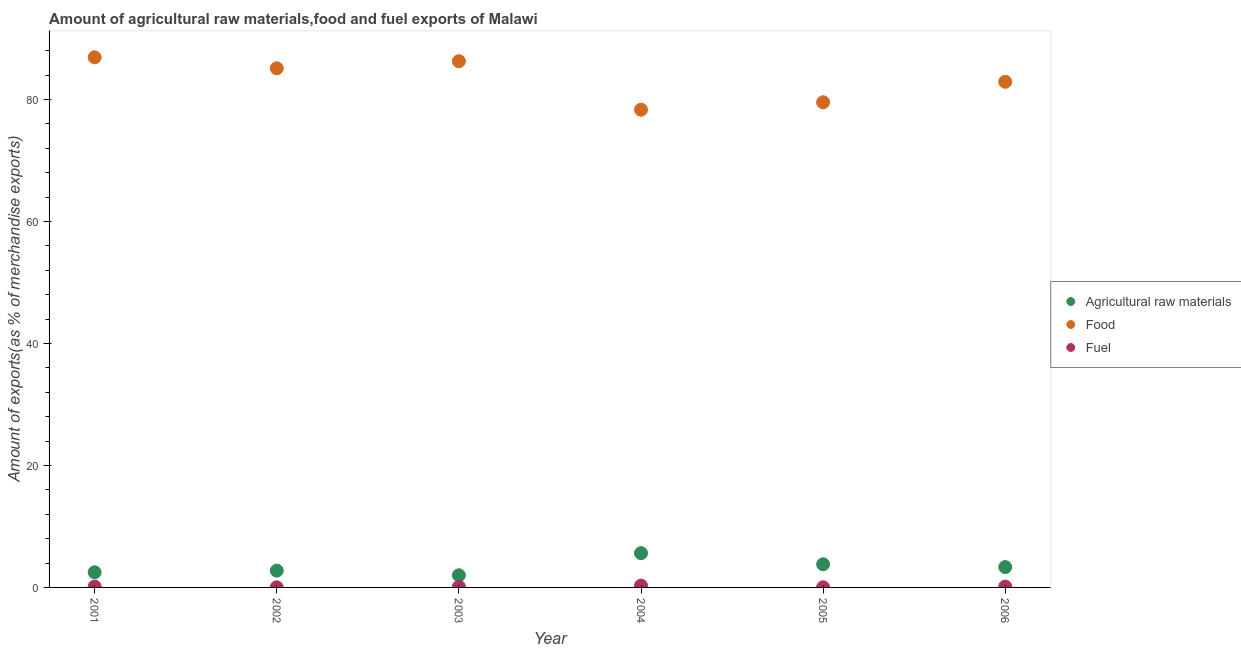Is the number of dotlines equal to the number of legend labels?
Ensure brevity in your answer.  Yes. What is the percentage of raw materials exports in 2006?
Make the answer very short. 3.33. Across all years, what is the maximum percentage of food exports?
Provide a succinct answer. 86.9. Across all years, what is the minimum percentage of food exports?
Your answer should be very brief. 78.32. In which year was the percentage of fuel exports maximum?
Make the answer very short. 2004. In which year was the percentage of fuel exports minimum?
Provide a succinct answer. 2002. What is the total percentage of fuel exports in the graph?
Make the answer very short. 0.73. What is the difference between the percentage of food exports in 2001 and that in 2003?
Make the answer very short. 0.64. What is the difference between the percentage of food exports in 2001 and the percentage of fuel exports in 2004?
Provide a succinct answer. 86.6. What is the average percentage of raw materials exports per year?
Provide a short and direct response. 3.33. In the year 2002, what is the difference between the percentage of fuel exports and percentage of food exports?
Your response must be concise. -85.09. In how many years, is the percentage of food exports greater than 68 %?
Ensure brevity in your answer.  6. What is the ratio of the percentage of food exports in 2001 to that in 2004?
Provide a succinct answer. 1.11. Is the percentage of raw materials exports in 2001 less than that in 2004?
Your answer should be very brief. Yes. Is the difference between the percentage of food exports in 2001 and 2002 greater than the difference between the percentage of raw materials exports in 2001 and 2002?
Give a very brief answer. Yes. What is the difference between the highest and the second highest percentage of food exports?
Keep it short and to the point. 0.64. What is the difference between the highest and the lowest percentage of raw materials exports?
Give a very brief answer. 3.62. In how many years, is the percentage of food exports greater than the average percentage of food exports taken over all years?
Make the answer very short. 3. Is it the case that in every year, the sum of the percentage of raw materials exports and percentage of food exports is greater than the percentage of fuel exports?
Your answer should be compact. Yes. Is the percentage of food exports strictly greater than the percentage of raw materials exports over the years?
Offer a very short reply. Yes. How many years are there in the graph?
Make the answer very short. 6. What is the difference between two consecutive major ticks on the Y-axis?
Keep it short and to the point. 20. Where does the legend appear in the graph?
Make the answer very short. Center right. How many legend labels are there?
Provide a succinct answer. 3. How are the legend labels stacked?
Your answer should be very brief. Vertical. What is the title of the graph?
Make the answer very short. Amount of agricultural raw materials,food and fuel exports of Malawi. Does "Transport services" appear as one of the legend labels in the graph?
Provide a short and direct response. No. What is the label or title of the X-axis?
Keep it short and to the point. Year. What is the label or title of the Y-axis?
Provide a short and direct response. Amount of exports(as % of merchandise exports). What is the Amount of exports(as % of merchandise exports) in Agricultural raw materials in 2001?
Offer a terse response. 2.48. What is the Amount of exports(as % of merchandise exports) of Food in 2001?
Keep it short and to the point. 86.9. What is the Amount of exports(as % of merchandise exports) in Fuel in 2001?
Offer a very short reply. 0.14. What is the Amount of exports(as % of merchandise exports) of Agricultural raw materials in 2002?
Offer a very short reply. 2.75. What is the Amount of exports(as % of merchandise exports) of Food in 2002?
Provide a short and direct response. 85.11. What is the Amount of exports(as % of merchandise exports) of Fuel in 2002?
Offer a terse response. 0.02. What is the Amount of exports(as % of merchandise exports) in Agricultural raw materials in 2003?
Ensure brevity in your answer.  2. What is the Amount of exports(as % of merchandise exports) in Food in 2003?
Ensure brevity in your answer.  86.27. What is the Amount of exports(as % of merchandise exports) in Fuel in 2003?
Your answer should be very brief. 0.11. What is the Amount of exports(as % of merchandise exports) in Agricultural raw materials in 2004?
Your answer should be compact. 5.62. What is the Amount of exports(as % of merchandise exports) of Food in 2004?
Give a very brief answer. 78.32. What is the Amount of exports(as % of merchandise exports) in Fuel in 2004?
Provide a succinct answer. 0.3. What is the Amount of exports(as % of merchandise exports) of Agricultural raw materials in 2005?
Make the answer very short. 3.8. What is the Amount of exports(as % of merchandise exports) in Food in 2005?
Give a very brief answer. 79.54. What is the Amount of exports(as % of merchandise exports) of Fuel in 2005?
Provide a succinct answer. 0.02. What is the Amount of exports(as % of merchandise exports) of Agricultural raw materials in 2006?
Your response must be concise. 3.33. What is the Amount of exports(as % of merchandise exports) in Food in 2006?
Give a very brief answer. 82.9. What is the Amount of exports(as % of merchandise exports) in Fuel in 2006?
Give a very brief answer. 0.14. Across all years, what is the maximum Amount of exports(as % of merchandise exports) in Agricultural raw materials?
Ensure brevity in your answer.  5.62. Across all years, what is the maximum Amount of exports(as % of merchandise exports) in Food?
Your answer should be compact. 86.9. Across all years, what is the maximum Amount of exports(as % of merchandise exports) of Fuel?
Offer a very short reply. 0.3. Across all years, what is the minimum Amount of exports(as % of merchandise exports) in Agricultural raw materials?
Make the answer very short. 2. Across all years, what is the minimum Amount of exports(as % of merchandise exports) in Food?
Provide a short and direct response. 78.32. Across all years, what is the minimum Amount of exports(as % of merchandise exports) of Fuel?
Your answer should be compact. 0.02. What is the total Amount of exports(as % of merchandise exports) of Agricultural raw materials in the graph?
Your answer should be very brief. 19.97. What is the total Amount of exports(as % of merchandise exports) in Food in the graph?
Offer a very short reply. 499.03. What is the total Amount of exports(as % of merchandise exports) of Fuel in the graph?
Give a very brief answer. 0.73. What is the difference between the Amount of exports(as % of merchandise exports) of Agricultural raw materials in 2001 and that in 2002?
Your answer should be compact. -0.28. What is the difference between the Amount of exports(as % of merchandise exports) in Food in 2001 and that in 2002?
Your answer should be compact. 1.8. What is the difference between the Amount of exports(as % of merchandise exports) of Fuel in 2001 and that in 2002?
Offer a terse response. 0.12. What is the difference between the Amount of exports(as % of merchandise exports) in Agricultural raw materials in 2001 and that in 2003?
Your answer should be very brief. 0.48. What is the difference between the Amount of exports(as % of merchandise exports) of Food in 2001 and that in 2003?
Make the answer very short. 0.64. What is the difference between the Amount of exports(as % of merchandise exports) in Fuel in 2001 and that in 2003?
Provide a short and direct response. 0.02. What is the difference between the Amount of exports(as % of merchandise exports) of Agricultural raw materials in 2001 and that in 2004?
Provide a succinct answer. -3.14. What is the difference between the Amount of exports(as % of merchandise exports) in Food in 2001 and that in 2004?
Provide a short and direct response. 8.59. What is the difference between the Amount of exports(as % of merchandise exports) in Fuel in 2001 and that in 2004?
Keep it short and to the point. -0.16. What is the difference between the Amount of exports(as % of merchandise exports) of Agricultural raw materials in 2001 and that in 2005?
Provide a short and direct response. -1.32. What is the difference between the Amount of exports(as % of merchandise exports) in Food in 2001 and that in 2005?
Your answer should be very brief. 7.37. What is the difference between the Amount of exports(as % of merchandise exports) of Fuel in 2001 and that in 2005?
Ensure brevity in your answer.  0.12. What is the difference between the Amount of exports(as % of merchandise exports) of Agricultural raw materials in 2001 and that in 2006?
Give a very brief answer. -0.86. What is the difference between the Amount of exports(as % of merchandise exports) of Food in 2001 and that in 2006?
Make the answer very short. 4.01. What is the difference between the Amount of exports(as % of merchandise exports) in Fuel in 2001 and that in 2006?
Your answer should be very brief. -0. What is the difference between the Amount of exports(as % of merchandise exports) of Agricultural raw materials in 2002 and that in 2003?
Provide a succinct answer. 0.76. What is the difference between the Amount of exports(as % of merchandise exports) of Food in 2002 and that in 2003?
Ensure brevity in your answer.  -1.16. What is the difference between the Amount of exports(as % of merchandise exports) of Fuel in 2002 and that in 2003?
Give a very brief answer. -0.09. What is the difference between the Amount of exports(as % of merchandise exports) of Agricultural raw materials in 2002 and that in 2004?
Offer a very short reply. -2.86. What is the difference between the Amount of exports(as % of merchandise exports) of Food in 2002 and that in 2004?
Make the answer very short. 6.79. What is the difference between the Amount of exports(as % of merchandise exports) of Fuel in 2002 and that in 2004?
Your response must be concise. -0.28. What is the difference between the Amount of exports(as % of merchandise exports) of Agricultural raw materials in 2002 and that in 2005?
Offer a terse response. -1.04. What is the difference between the Amount of exports(as % of merchandise exports) of Food in 2002 and that in 2005?
Provide a short and direct response. 5.57. What is the difference between the Amount of exports(as % of merchandise exports) in Fuel in 2002 and that in 2005?
Give a very brief answer. -0. What is the difference between the Amount of exports(as % of merchandise exports) in Agricultural raw materials in 2002 and that in 2006?
Give a very brief answer. -0.58. What is the difference between the Amount of exports(as % of merchandise exports) in Food in 2002 and that in 2006?
Provide a short and direct response. 2.21. What is the difference between the Amount of exports(as % of merchandise exports) of Fuel in 2002 and that in 2006?
Provide a short and direct response. -0.12. What is the difference between the Amount of exports(as % of merchandise exports) in Agricultural raw materials in 2003 and that in 2004?
Ensure brevity in your answer.  -3.62. What is the difference between the Amount of exports(as % of merchandise exports) of Food in 2003 and that in 2004?
Provide a short and direct response. 7.95. What is the difference between the Amount of exports(as % of merchandise exports) in Fuel in 2003 and that in 2004?
Ensure brevity in your answer.  -0.19. What is the difference between the Amount of exports(as % of merchandise exports) of Agricultural raw materials in 2003 and that in 2005?
Offer a terse response. -1.8. What is the difference between the Amount of exports(as % of merchandise exports) in Food in 2003 and that in 2005?
Your answer should be compact. 6.73. What is the difference between the Amount of exports(as % of merchandise exports) in Fuel in 2003 and that in 2005?
Make the answer very short. 0.09. What is the difference between the Amount of exports(as % of merchandise exports) of Agricultural raw materials in 2003 and that in 2006?
Give a very brief answer. -1.34. What is the difference between the Amount of exports(as % of merchandise exports) of Food in 2003 and that in 2006?
Your answer should be very brief. 3.37. What is the difference between the Amount of exports(as % of merchandise exports) in Fuel in 2003 and that in 2006?
Your answer should be very brief. -0.03. What is the difference between the Amount of exports(as % of merchandise exports) in Agricultural raw materials in 2004 and that in 2005?
Give a very brief answer. 1.82. What is the difference between the Amount of exports(as % of merchandise exports) in Food in 2004 and that in 2005?
Offer a terse response. -1.22. What is the difference between the Amount of exports(as % of merchandise exports) in Fuel in 2004 and that in 2005?
Offer a very short reply. 0.28. What is the difference between the Amount of exports(as % of merchandise exports) in Agricultural raw materials in 2004 and that in 2006?
Give a very brief answer. 2.28. What is the difference between the Amount of exports(as % of merchandise exports) in Food in 2004 and that in 2006?
Keep it short and to the point. -4.58. What is the difference between the Amount of exports(as % of merchandise exports) in Fuel in 2004 and that in 2006?
Ensure brevity in your answer.  0.16. What is the difference between the Amount of exports(as % of merchandise exports) of Agricultural raw materials in 2005 and that in 2006?
Ensure brevity in your answer.  0.46. What is the difference between the Amount of exports(as % of merchandise exports) of Food in 2005 and that in 2006?
Give a very brief answer. -3.36. What is the difference between the Amount of exports(as % of merchandise exports) of Fuel in 2005 and that in 2006?
Your answer should be very brief. -0.12. What is the difference between the Amount of exports(as % of merchandise exports) in Agricultural raw materials in 2001 and the Amount of exports(as % of merchandise exports) in Food in 2002?
Make the answer very short. -82.63. What is the difference between the Amount of exports(as % of merchandise exports) of Agricultural raw materials in 2001 and the Amount of exports(as % of merchandise exports) of Fuel in 2002?
Your response must be concise. 2.46. What is the difference between the Amount of exports(as % of merchandise exports) of Food in 2001 and the Amount of exports(as % of merchandise exports) of Fuel in 2002?
Your answer should be compact. 86.89. What is the difference between the Amount of exports(as % of merchandise exports) of Agricultural raw materials in 2001 and the Amount of exports(as % of merchandise exports) of Food in 2003?
Offer a terse response. -83.79. What is the difference between the Amount of exports(as % of merchandise exports) of Agricultural raw materials in 2001 and the Amount of exports(as % of merchandise exports) of Fuel in 2003?
Ensure brevity in your answer.  2.36. What is the difference between the Amount of exports(as % of merchandise exports) in Food in 2001 and the Amount of exports(as % of merchandise exports) in Fuel in 2003?
Provide a short and direct response. 86.79. What is the difference between the Amount of exports(as % of merchandise exports) in Agricultural raw materials in 2001 and the Amount of exports(as % of merchandise exports) in Food in 2004?
Your answer should be very brief. -75.84. What is the difference between the Amount of exports(as % of merchandise exports) of Agricultural raw materials in 2001 and the Amount of exports(as % of merchandise exports) of Fuel in 2004?
Your answer should be compact. 2.18. What is the difference between the Amount of exports(as % of merchandise exports) in Food in 2001 and the Amount of exports(as % of merchandise exports) in Fuel in 2004?
Your response must be concise. 86.6. What is the difference between the Amount of exports(as % of merchandise exports) of Agricultural raw materials in 2001 and the Amount of exports(as % of merchandise exports) of Food in 2005?
Ensure brevity in your answer.  -77.06. What is the difference between the Amount of exports(as % of merchandise exports) in Agricultural raw materials in 2001 and the Amount of exports(as % of merchandise exports) in Fuel in 2005?
Provide a short and direct response. 2.46. What is the difference between the Amount of exports(as % of merchandise exports) of Food in 2001 and the Amount of exports(as % of merchandise exports) of Fuel in 2005?
Your answer should be compact. 86.88. What is the difference between the Amount of exports(as % of merchandise exports) of Agricultural raw materials in 2001 and the Amount of exports(as % of merchandise exports) of Food in 2006?
Give a very brief answer. -80.42. What is the difference between the Amount of exports(as % of merchandise exports) in Agricultural raw materials in 2001 and the Amount of exports(as % of merchandise exports) in Fuel in 2006?
Keep it short and to the point. 2.34. What is the difference between the Amount of exports(as % of merchandise exports) in Food in 2001 and the Amount of exports(as % of merchandise exports) in Fuel in 2006?
Offer a very short reply. 86.77. What is the difference between the Amount of exports(as % of merchandise exports) in Agricultural raw materials in 2002 and the Amount of exports(as % of merchandise exports) in Food in 2003?
Keep it short and to the point. -83.51. What is the difference between the Amount of exports(as % of merchandise exports) in Agricultural raw materials in 2002 and the Amount of exports(as % of merchandise exports) in Fuel in 2003?
Your answer should be very brief. 2.64. What is the difference between the Amount of exports(as % of merchandise exports) in Food in 2002 and the Amount of exports(as % of merchandise exports) in Fuel in 2003?
Offer a very short reply. 84.99. What is the difference between the Amount of exports(as % of merchandise exports) of Agricultural raw materials in 2002 and the Amount of exports(as % of merchandise exports) of Food in 2004?
Offer a terse response. -75.56. What is the difference between the Amount of exports(as % of merchandise exports) of Agricultural raw materials in 2002 and the Amount of exports(as % of merchandise exports) of Fuel in 2004?
Your answer should be very brief. 2.45. What is the difference between the Amount of exports(as % of merchandise exports) in Food in 2002 and the Amount of exports(as % of merchandise exports) in Fuel in 2004?
Offer a terse response. 84.81. What is the difference between the Amount of exports(as % of merchandise exports) of Agricultural raw materials in 2002 and the Amount of exports(as % of merchandise exports) of Food in 2005?
Provide a short and direct response. -76.79. What is the difference between the Amount of exports(as % of merchandise exports) of Agricultural raw materials in 2002 and the Amount of exports(as % of merchandise exports) of Fuel in 2005?
Keep it short and to the point. 2.73. What is the difference between the Amount of exports(as % of merchandise exports) in Food in 2002 and the Amount of exports(as % of merchandise exports) in Fuel in 2005?
Your answer should be compact. 85.09. What is the difference between the Amount of exports(as % of merchandise exports) in Agricultural raw materials in 2002 and the Amount of exports(as % of merchandise exports) in Food in 2006?
Give a very brief answer. -80.14. What is the difference between the Amount of exports(as % of merchandise exports) in Agricultural raw materials in 2002 and the Amount of exports(as % of merchandise exports) in Fuel in 2006?
Keep it short and to the point. 2.61. What is the difference between the Amount of exports(as % of merchandise exports) of Food in 2002 and the Amount of exports(as % of merchandise exports) of Fuel in 2006?
Make the answer very short. 84.97. What is the difference between the Amount of exports(as % of merchandise exports) in Agricultural raw materials in 2003 and the Amount of exports(as % of merchandise exports) in Food in 2004?
Your answer should be very brief. -76.32. What is the difference between the Amount of exports(as % of merchandise exports) of Agricultural raw materials in 2003 and the Amount of exports(as % of merchandise exports) of Fuel in 2004?
Your answer should be very brief. 1.7. What is the difference between the Amount of exports(as % of merchandise exports) of Food in 2003 and the Amount of exports(as % of merchandise exports) of Fuel in 2004?
Your answer should be compact. 85.97. What is the difference between the Amount of exports(as % of merchandise exports) of Agricultural raw materials in 2003 and the Amount of exports(as % of merchandise exports) of Food in 2005?
Your answer should be compact. -77.54. What is the difference between the Amount of exports(as % of merchandise exports) in Agricultural raw materials in 2003 and the Amount of exports(as % of merchandise exports) in Fuel in 2005?
Give a very brief answer. 1.97. What is the difference between the Amount of exports(as % of merchandise exports) in Food in 2003 and the Amount of exports(as % of merchandise exports) in Fuel in 2005?
Give a very brief answer. 86.25. What is the difference between the Amount of exports(as % of merchandise exports) in Agricultural raw materials in 2003 and the Amount of exports(as % of merchandise exports) in Food in 2006?
Ensure brevity in your answer.  -80.9. What is the difference between the Amount of exports(as % of merchandise exports) in Agricultural raw materials in 2003 and the Amount of exports(as % of merchandise exports) in Fuel in 2006?
Provide a succinct answer. 1.86. What is the difference between the Amount of exports(as % of merchandise exports) of Food in 2003 and the Amount of exports(as % of merchandise exports) of Fuel in 2006?
Offer a terse response. 86.13. What is the difference between the Amount of exports(as % of merchandise exports) of Agricultural raw materials in 2004 and the Amount of exports(as % of merchandise exports) of Food in 2005?
Your answer should be very brief. -73.92. What is the difference between the Amount of exports(as % of merchandise exports) in Agricultural raw materials in 2004 and the Amount of exports(as % of merchandise exports) in Fuel in 2005?
Provide a succinct answer. 5.6. What is the difference between the Amount of exports(as % of merchandise exports) in Food in 2004 and the Amount of exports(as % of merchandise exports) in Fuel in 2005?
Give a very brief answer. 78.3. What is the difference between the Amount of exports(as % of merchandise exports) of Agricultural raw materials in 2004 and the Amount of exports(as % of merchandise exports) of Food in 2006?
Ensure brevity in your answer.  -77.28. What is the difference between the Amount of exports(as % of merchandise exports) in Agricultural raw materials in 2004 and the Amount of exports(as % of merchandise exports) in Fuel in 2006?
Your answer should be compact. 5.48. What is the difference between the Amount of exports(as % of merchandise exports) of Food in 2004 and the Amount of exports(as % of merchandise exports) of Fuel in 2006?
Offer a terse response. 78.18. What is the difference between the Amount of exports(as % of merchandise exports) in Agricultural raw materials in 2005 and the Amount of exports(as % of merchandise exports) in Food in 2006?
Offer a terse response. -79.1. What is the difference between the Amount of exports(as % of merchandise exports) in Agricultural raw materials in 2005 and the Amount of exports(as % of merchandise exports) in Fuel in 2006?
Your answer should be very brief. 3.66. What is the difference between the Amount of exports(as % of merchandise exports) of Food in 2005 and the Amount of exports(as % of merchandise exports) of Fuel in 2006?
Provide a short and direct response. 79.4. What is the average Amount of exports(as % of merchandise exports) in Agricultural raw materials per year?
Your response must be concise. 3.33. What is the average Amount of exports(as % of merchandise exports) of Food per year?
Your answer should be compact. 83.17. What is the average Amount of exports(as % of merchandise exports) of Fuel per year?
Offer a terse response. 0.12. In the year 2001, what is the difference between the Amount of exports(as % of merchandise exports) in Agricultural raw materials and Amount of exports(as % of merchandise exports) in Food?
Keep it short and to the point. -84.43. In the year 2001, what is the difference between the Amount of exports(as % of merchandise exports) of Agricultural raw materials and Amount of exports(as % of merchandise exports) of Fuel?
Offer a very short reply. 2.34. In the year 2001, what is the difference between the Amount of exports(as % of merchandise exports) in Food and Amount of exports(as % of merchandise exports) in Fuel?
Provide a succinct answer. 86.77. In the year 2002, what is the difference between the Amount of exports(as % of merchandise exports) in Agricultural raw materials and Amount of exports(as % of merchandise exports) in Food?
Ensure brevity in your answer.  -82.35. In the year 2002, what is the difference between the Amount of exports(as % of merchandise exports) of Agricultural raw materials and Amount of exports(as % of merchandise exports) of Fuel?
Provide a short and direct response. 2.74. In the year 2002, what is the difference between the Amount of exports(as % of merchandise exports) in Food and Amount of exports(as % of merchandise exports) in Fuel?
Ensure brevity in your answer.  85.09. In the year 2003, what is the difference between the Amount of exports(as % of merchandise exports) of Agricultural raw materials and Amount of exports(as % of merchandise exports) of Food?
Give a very brief answer. -84.27. In the year 2003, what is the difference between the Amount of exports(as % of merchandise exports) in Agricultural raw materials and Amount of exports(as % of merchandise exports) in Fuel?
Offer a terse response. 1.88. In the year 2003, what is the difference between the Amount of exports(as % of merchandise exports) of Food and Amount of exports(as % of merchandise exports) of Fuel?
Your answer should be very brief. 86.16. In the year 2004, what is the difference between the Amount of exports(as % of merchandise exports) of Agricultural raw materials and Amount of exports(as % of merchandise exports) of Food?
Make the answer very short. -72.7. In the year 2004, what is the difference between the Amount of exports(as % of merchandise exports) in Agricultural raw materials and Amount of exports(as % of merchandise exports) in Fuel?
Offer a very short reply. 5.32. In the year 2004, what is the difference between the Amount of exports(as % of merchandise exports) of Food and Amount of exports(as % of merchandise exports) of Fuel?
Provide a succinct answer. 78.02. In the year 2005, what is the difference between the Amount of exports(as % of merchandise exports) of Agricultural raw materials and Amount of exports(as % of merchandise exports) of Food?
Offer a terse response. -75.74. In the year 2005, what is the difference between the Amount of exports(as % of merchandise exports) in Agricultural raw materials and Amount of exports(as % of merchandise exports) in Fuel?
Your response must be concise. 3.78. In the year 2005, what is the difference between the Amount of exports(as % of merchandise exports) of Food and Amount of exports(as % of merchandise exports) of Fuel?
Keep it short and to the point. 79.52. In the year 2006, what is the difference between the Amount of exports(as % of merchandise exports) of Agricultural raw materials and Amount of exports(as % of merchandise exports) of Food?
Make the answer very short. -79.56. In the year 2006, what is the difference between the Amount of exports(as % of merchandise exports) of Agricultural raw materials and Amount of exports(as % of merchandise exports) of Fuel?
Make the answer very short. 3.2. In the year 2006, what is the difference between the Amount of exports(as % of merchandise exports) in Food and Amount of exports(as % of merchandise exports) in Fuel?
Keep it short and to the point. 82.76. What is the ratio of the Amount of exports(as % of merchandise exports) in Agricultural raw materials in 2001 to that in 2002?
Your answer should be very brief. 0.9. What is the ratio of the Amount of exports(as % of merchandise exports) of Food in 2001 to that in 2002?
Provide a short and direct response. 1.02. What is the ratio of the Amount of exports(as % of merchandise exports) of Fuel in 2001 to that in 2002?
Provide a short and direct response. 7.55. What is the ratio of the Amount of exports(as % of merchandise exports) of Agricultural raw materials in 2001 to that in 2003?
Provide a short and direct response. 1.24. What is the ratio of the Amount of exports(as % of merchandise exports) in Food in 2001 to that in 2003?
Your answer should be very brief. 1.01. What is the ratio of the Amount of exports(as % of merchandise exports) of Fuel in 2001 to that in 2003?
Provide a succinct answer. 1.21. What is the ratio of the Amount of exports(as % of merchandise exports) in Agricultural raw materials in 2001 to that in 2004?
Give a very brief answer. 0.44. What is the ratio of the Amount of exports(as % of merchandise exports) in Food in 2001 to that in 2004?
Keep it short and to the point. 1.11. What is the ratio of the Amount of exports(as % of merchandise exports) of Fuel in 2001 to that in 2004?
Ensure brevity in your answer.  0.45. What is the ratio of the Amount of exports(as % of merchandise exports) of Agricultural raw materials in 2001 to that in 2005?
Your answer should be very brief. 0.65. What is the ratio of the Amount of exports(as % of merchandise exports) of Food in 2001 to that in 2005?
Keep it short and to the point. 1.09. What is the ratio of the Amount of exports(as % of merchandise exports) in Fuel in 2001 to that in 2005?
Offer a very short reply. 6.66. What is the ratio of the Amount of exports(as % of merchandise exports) of Agricultural raw materials in 2001 to that in 2006?
Offer a very short reply. 0.74. What is the ratio of the Amount of exports(as % of merchandise exports) in Food in 2001 to that in 2006?
Offer a terse response. 1.05. What is the ratio of the Amount of exports(as % of merchandise exports) of Fuel in 2001 to that in 2006?
Your answer should be very brief. 0.98. What is the ratio of the Amount of exports(as % of merchandise exports) in Agricultural raw materials in 2002 to that in 2003?
Your answer should be very brief. 1.38. What is the ratio of the Amount of exports(as % of merchandise exports) in Food in 2002 to that in 2003?
Provide a succinct answer. 0.99. What is the ratio of the Amount of exports(as % of merchandise exports) in Fuel in 2002 to that in 2003?
Provide a short and direct response. 0.16. What is the ratio of the Amount of exports(as % of merchandise exports) in Agricultural raw materials in 2002 to that in 2004?
Your answer should be compact. 0.49. What is the ratio of the Amount of exports(as % of merchandise exports) in Food in 2002 to that in 2004?
Offer a terse response. 1.09. What is the ratio of the Amount of exports(as % of merchandise exports) in Fuel in 2002 to that in 2004?
Your answer should be very brief. 0.06. What is the ratio of the Amount of exports(as % of merchandise exports) of Agricultural raw materials in 2002 to that in 2005?
Make the answer very short. 0.73. What is the ratio of the Amount of exports(as % of merchandise exports) of Food in 2002 to that in 2005?
Keep it short and to the point. 1.07. What is the ratio of the Amount of exports(as % of merchandise exports) of Fuel in 2002 to that in 2005?
Provide a short and direct response. 0.88. What is the ratio of the Amount of exports(as % of merchandise exports) in Agricultural raw materials in 2002 to that in 2006?
Your answer should be very brief. 0.83. What is the ratio of the Amount of exports(as % of merchandise exports) of Food in 2002 to that in 2006?
Offer a very short reply. 1.03. What is the ratio of the Amount of exports(as % of merchandise exports) in Fuel in 2002 to that in 2006?
Offer a terse response. 0.13. What is the ratio of the Amount of exports(as % of merchandise exports) in Agricultural raw materials in 2003 to that in 2004?
Offer a very short reply. 0.36. What is the ratio of the Amount of exports(as % of merchandise exports) of Food in 2003 to that in 2004?
Keep it short and to the point. 1.1. What is the ratio of the Amount of exports(as % of merchandise exports) in Fuel in 2003 to that in 2004?
Provide a succinct answer. 0.37. What is the ratio of the Amount of exports(as % of merchandise exports) in Agricultural raw materials in 2003 to that in 2005?
Your response must be concise. 0.53. What is the ratio of the Amount of exports(as % of merchandise exports) in Food in 2003 to that in 2005?
Your answer should be compact. 1.08. What is the ratio of the Amount of exports(as % of merchandise exports) of Fuel in 2003 to that in 2005?
Your answer should be very brief. 5.48. What is the ratio of the Amount of exports(as % of merchandise exports) of Agricultural raw materials in 2003 to that in 2006?
Offer a terse response. 0.6. What is the ratio of the Amount of exports(as % of merchandise exports) in Food in 2003 to that in 2006?
Give a very brief answer. 1.04. What is the ratio of the Amount of exports(as % of merchandise exports) of Fuel in 2003 to that in 2006?
Offer a terse response. 0.8. What is the ratio of the Amount of exports(as % of merchandise exports) of Agricultural raw materials in 2004 to that in 2005?
Provide a succinct answer. 1.48. What is the ratio of the Amount of exports(as % of merchandise exports) of Food in 2004 to that in 2005?
Provide a short and direct response. 0.98. What is the ratio of the Amount of exports(as % of merchandise exports) in Fuel in 2004 to that in 2005?
Your answer should be compact. 14.64. What is the ratio of the Amount of exports(as % of merchandise exports) of Agricultural raw materials in 2004 to that in 2006?
Your response must be concise. 1.68. What is the ratio of the Amount of exports(as % of merchandise exports) in Food in 2004 to that in 2006?
Make the answer very short. 0.94. What is the ratio of the Amount of exports(as % of merchandise exports) of Fuel in 2004 to that in 2006?
Give a very brief answer. 2.15. What is the ratio of the Amount of exports(as % of merchandise exports) in Agricultural raw materials in 2005 to that in 2006?
Keep it short and to the point. 1.14. What is the ratio of the Amount of exports(as % of merchandise exports) in Food in 2005 to that in 2006?
Your answer should be very brief. 0.96. What is the ratio of the Amount of exports(as % of merchandise exports) of Fuel in 2005 to that in 2006?
Ensure brevity in your answer.  0.15. What is the difference between the highest and the second highest Amount of exports(as % of merchandise exports) of Agricultural raw materials?
Provide a short and direct response. 1.82. What is the difference between the highest and the second highest Amount of exports(as % of merchandise exports) of Food?
Give a very brief answer. 0.64. What is the difference between the highest and the second highest Amount of exports(as % of merchandise exports) in Fuel?
Ensure brevity in your answer.  0.16. What is the difference between the highest and the lowest Amount of exports(as % of merchandise exports) in Agricultural raw materials?
Give a very brief answer. 3.62. What is the difference between the highest and the lowest Amount of exports(as % of merchandise exports) in Food?
Keep it short and to the point. 8.59. What is the difference between the highest and the lowest Amount of exports(as % of merchandise exports) of Fuel?
Provide a succinct answer. 0.28. 